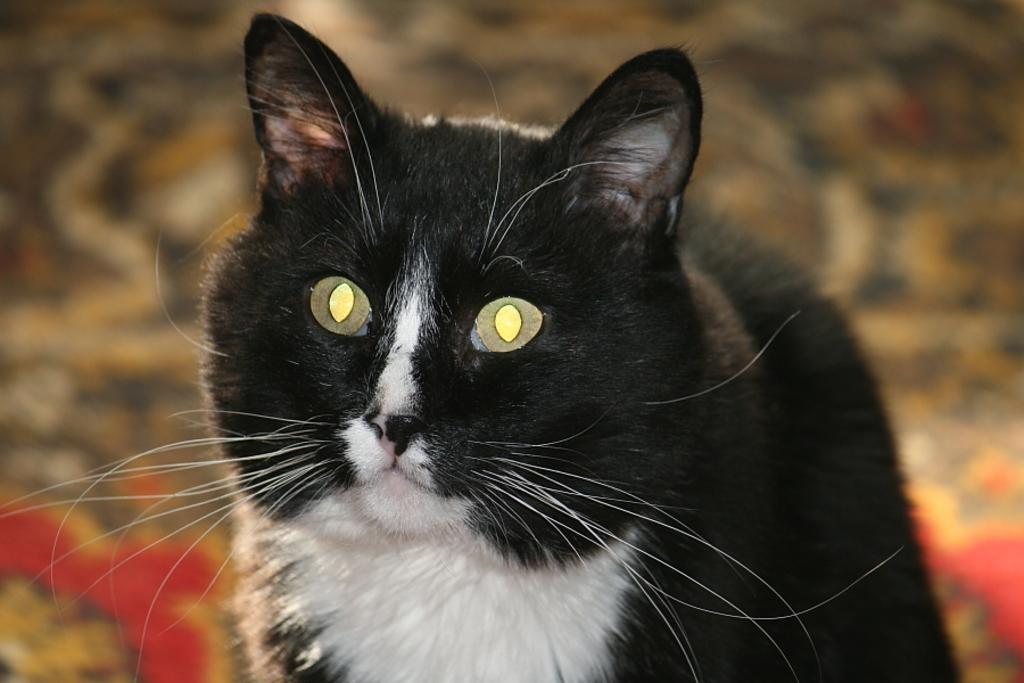What type of animal is in the image? There is a cat in the image. Where is the cat located in the image? The cat is on a surface. How many horses are visible in the image? There are no horses present in the image; it features a cat on a surface. What type of beam is supporting the wall in the image? There is no wall or beam present in the image; it features a cat on a surface. 